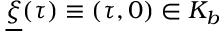Convert formula to latex. <formula><loc_0><loc_0><loc_500><loc_500>\underline { \xi } ( \tau ) \equiv \left ( \tau , 0 \right ) \in K _ { b }</formula> 